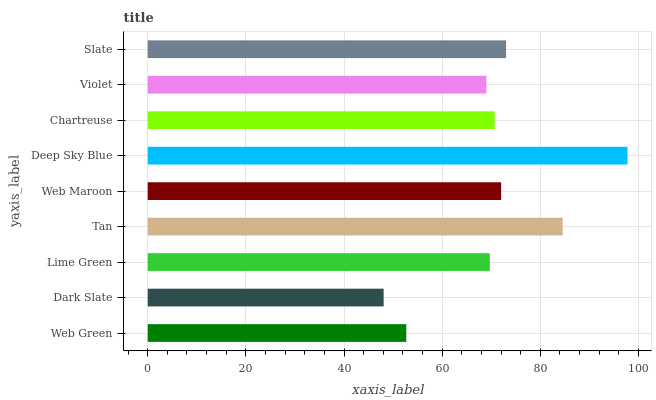Is Dark Slate the minimum?
Answer yes or no. Yes. Is Deep Sky Blue the maximum?
Answer yes or no. Yes. Is Lime Green the minimum?
Answer yes or no. No. Is Lime Green the maximum?
Answer yes or no. No. Is Lime Green greater than Dark Slate?
Answer yes or no. Yes. Is Dark Slate less than Lime Green?
Answer yes or no. Yes. Is Dark Slate greater than Lime Green?
Answer yes or no. No. Is Lime Green less than Dark Slate?
Answer yes or no. No. Is Chartreuse the high median?
Answer yes or no. Yes. Is Chartreuse the low median?
Answer yes or no. Yes. Is Slate the high median?
Answer yes or no. No. Is Dark Slate the low median?
Answer yes or no. No. 